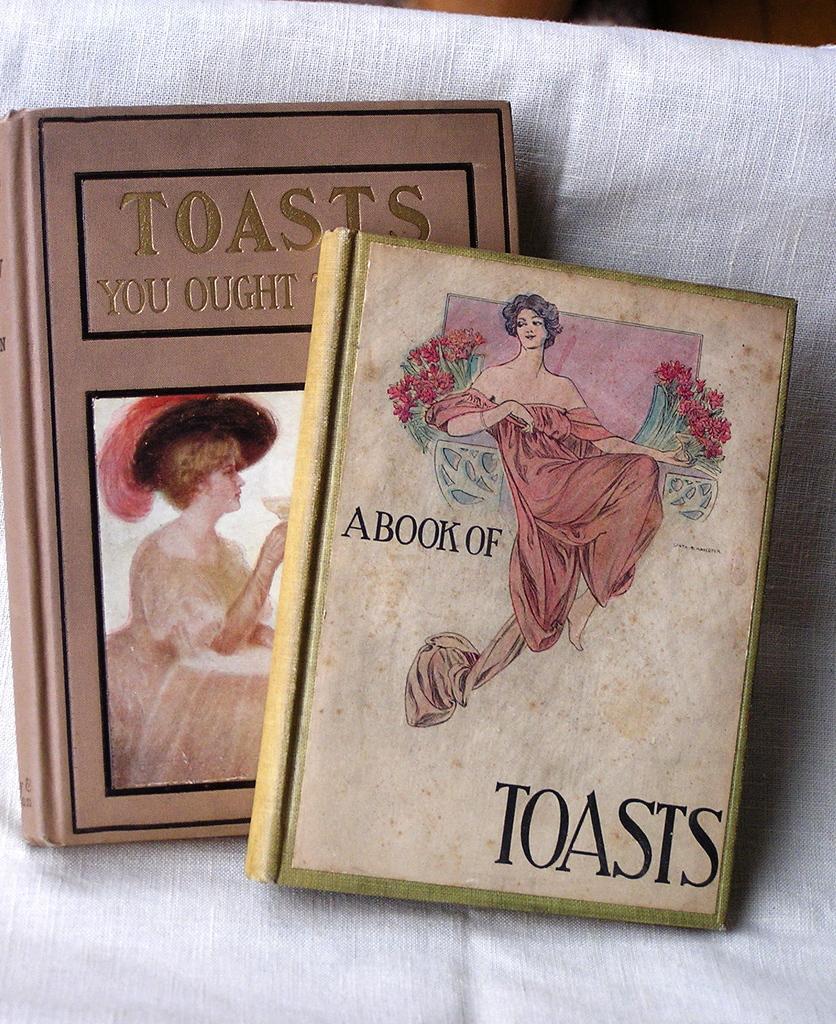Could you give a brief overview of what you see in this image? In this image I see the white color cloth on which there are 2 books and I see depiction of women pictures and I see words written on those books. 